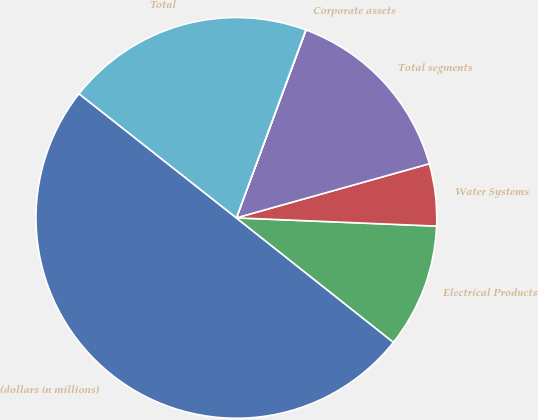Convert chart. <chart><loc_0><loc_0><loc_500><loc_500><pie_chart><fcel>(dollars in millions)<fcel>Electrical Products<fcel>Water Systems<fcel>Total segments<fcel>Corporate assets<fcel>Total<nl><fcel>49.97%<fcel>10.01%<fcel>5.01%<fcel>15.0%<fcel>0.02%<fcel>20.0%<nl></chart> 